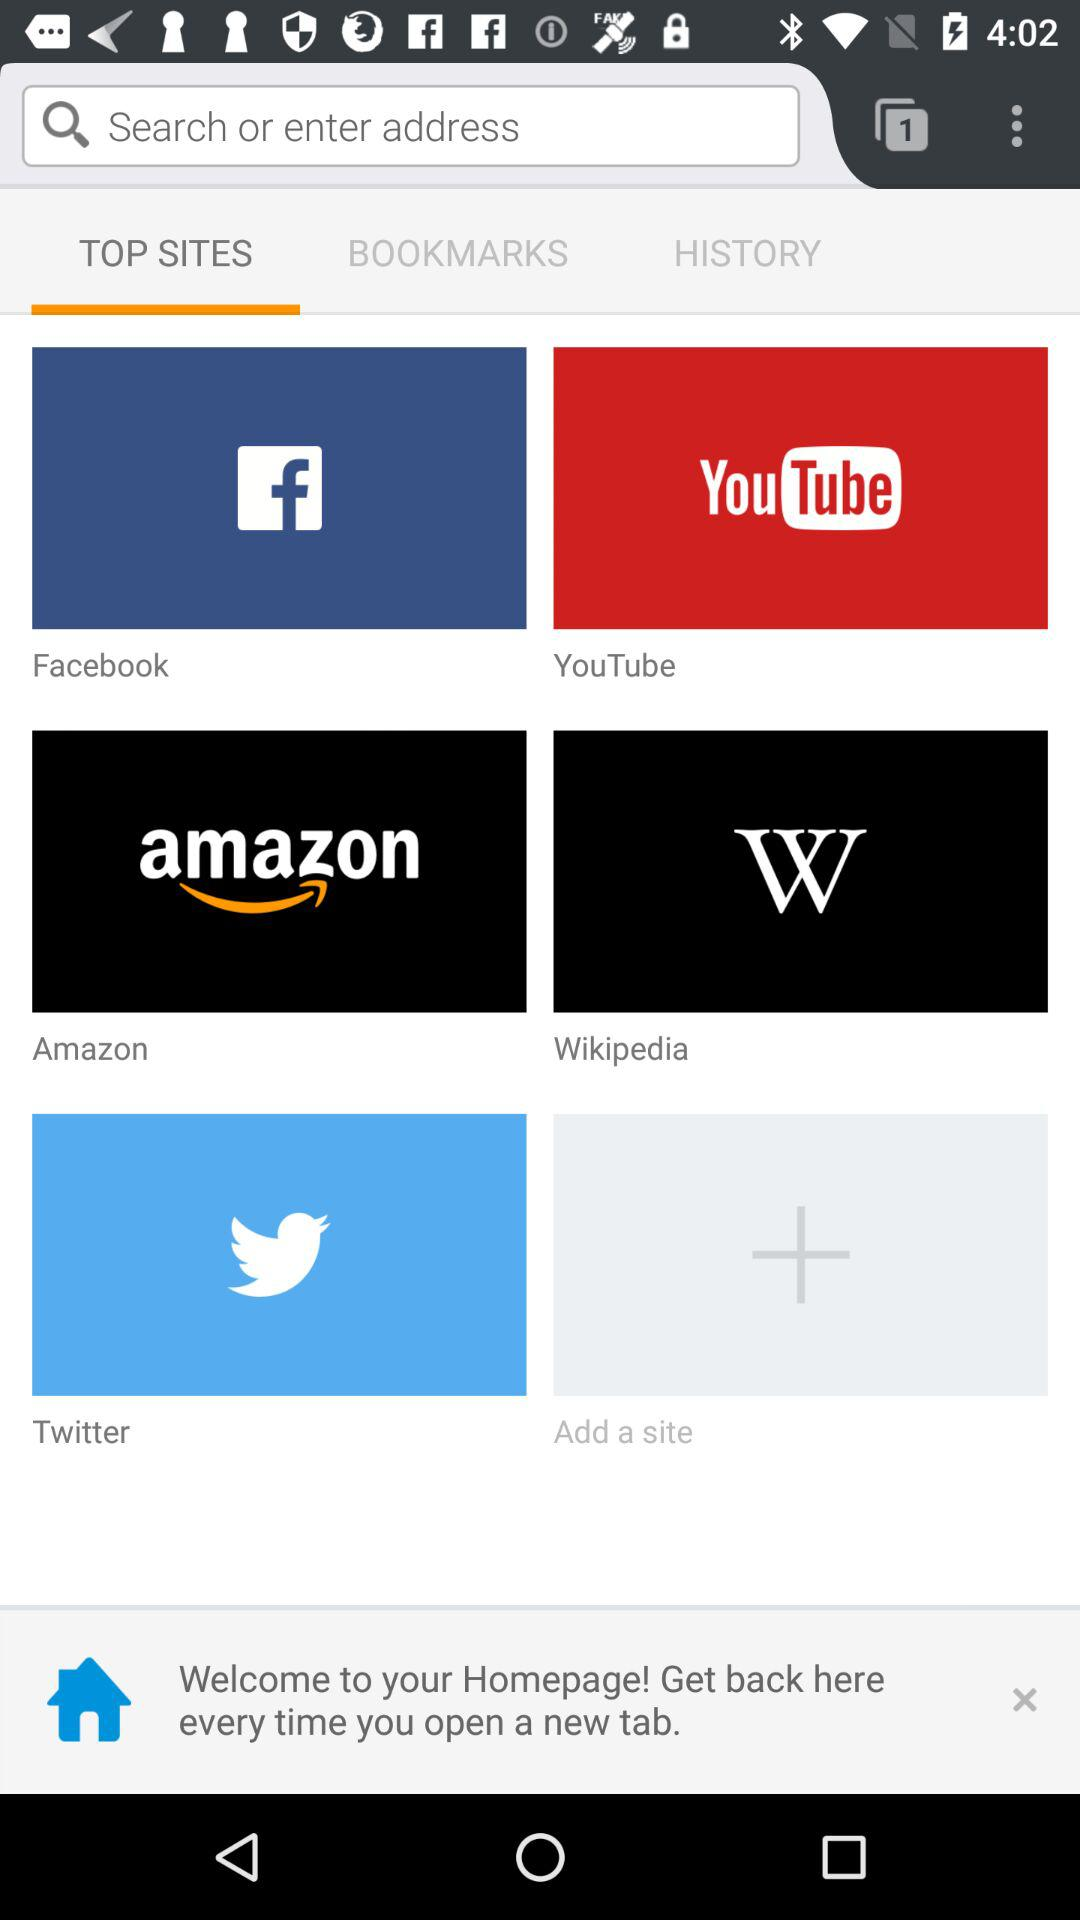Which tab is selected? The selected tab is "TOP SITES". 